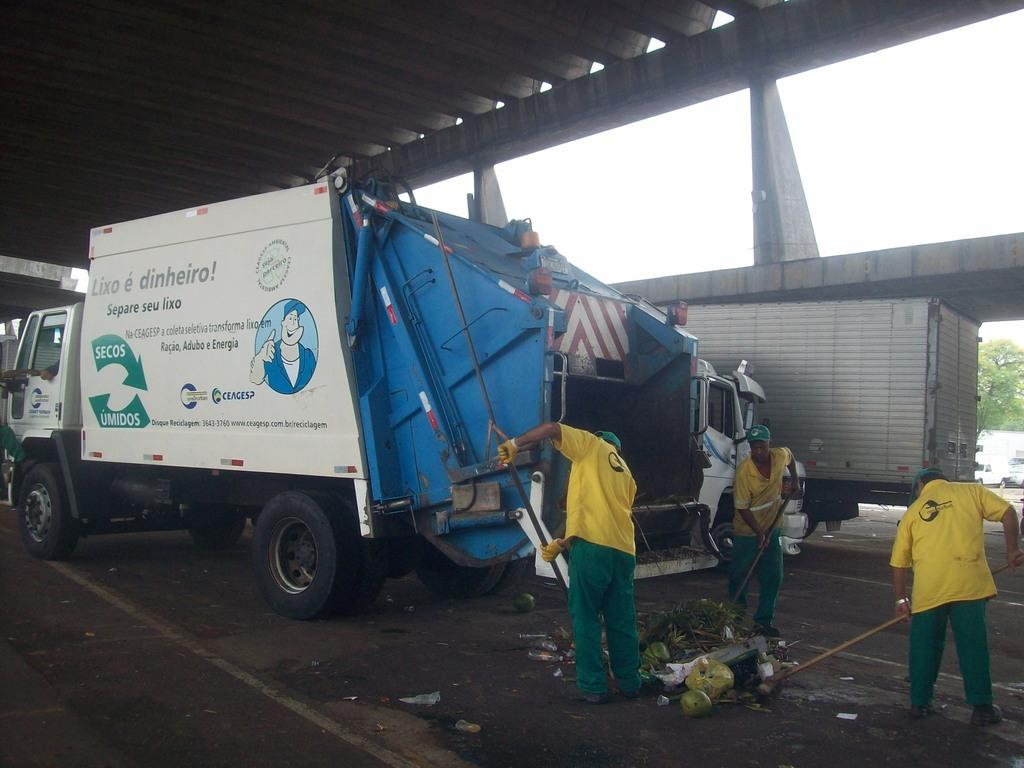What can be seen in the image that moves on roads? There are vehicles in the image that move on roads. How many people are standing on the road in the image? There are three people standing on the road in the image. What type of vegetation is present in the image? There are trees in the image. What is visible in the background of the image? The sky is visible in the background of the image. What type of shoe is being used to measure the heat in the image? There is no shoe or measurement of heat present in the image. How does the motion of the vehicles affect the trees in the image? The motion of the vehicles does not affect the trees in the image, as they are stationary objects. 